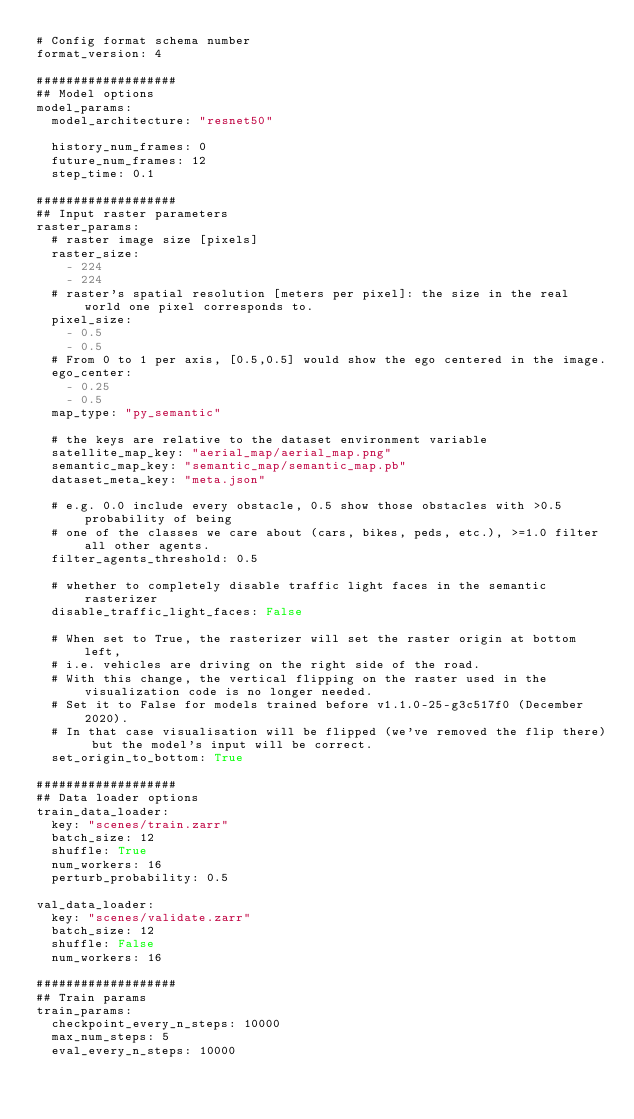Convert code to text. <code><loc_0><loc_0><loc_500><loc_500><_YAML_># Config format schema number
format_version: 4

###################
## Model options
model_params:
  model_architecture: "resnet50"

  history_num_frames: 0
  future_num_frames: 12
  step_time: 0.1

###################
## Input raster parameters
raster_params:
  # raster image size [pixels]
  raster_size:
    - 224
    - 224
  # raster's spatial resolution [meters per pixel]: the size in the real world one pixel corresponds to.
  pixel_size:
    - 0.5
    - 0.5
  # From 0 to 1 per axis, [0.5,0.5] would show the ego centered in the image.
  ego_center:
    - 0.25
    - 0.5
  map_type: "py_semantic"

  # the keys are relative to the dataset environment variable
  satellite_map_key: "aerial_map/aerial_map.png"
  semantic_map_key: "semantic_map/semantic_map.pb"
  dataset_meta_key: "meta.json"

  # e.g. 0.0 include every obstacle, 0.5 show those obstacles with >0.5 probability of being
  # one of the classes we care about (cars, bikes, peds, etc.), >=1.0 filter all other agents.
  filter_agents_threshold: 0.5

  # whether to completely disable traffic light faces in the semantic rasterizer
  disable_traffic_light_faces: False

  # When set to True, the rasterizer will set the raster origin at bottom left,
  # i.e. vehicles are driving on the right side of the road.
  # With this change, the vertical flipping on the raster used in the visualization code is no longer needed.
  # Set it to False for models trained before v1.1.0-25-g3c517f0 (December 2020).
  # In that case visualisation will be flipped (we've removed the flip there) but the model's input will be correct.
  set_origin_to_bottom: True

###################
## Data loader options
train_data_loader:
  key: "scenes/train.zarr"
  batch_size: 12
  shuffle: True
  num_workers: 16
  perturb_probability: 0.5

val_data_loader:
  key: "scenes/validate.zarr"
  batch_size: 12
  shuffle: False
  num_workers: 16

###################
## Train params
train_params:
  checkpoint_every_n_steps: 10000
  max_num_steps: 5
  eval_every_n_steps: 10000
</code> 